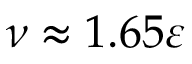<formula> <loc_0><loc_0><loc_500><loc_500>\nu \approx 1 . 6 5 \varepsilon</formula> 